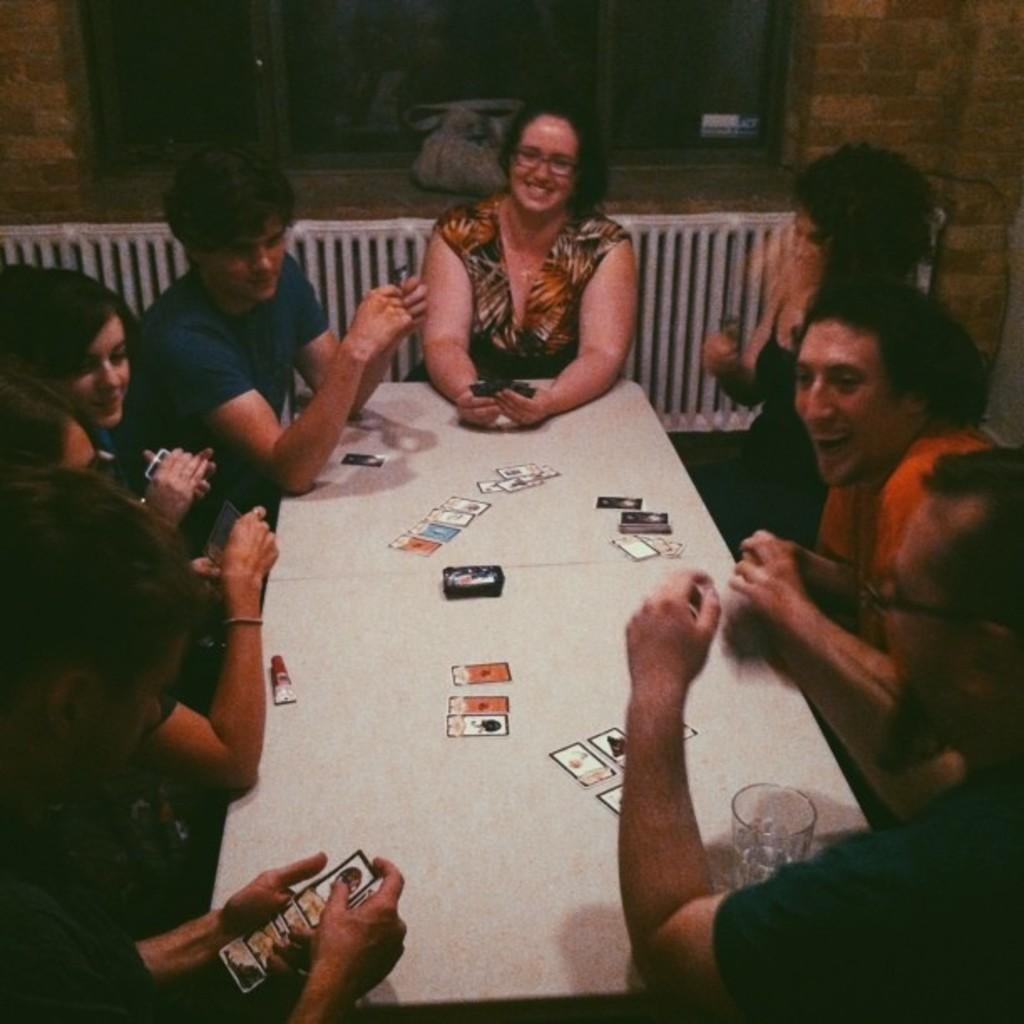What are the people in the image doing? The people in the image are sitting on chairs. What objects can be seen on the table in the image? There are cards on a table in the image. What type of pencil can be seen being used by the people in the image? There is no pencil present in the image. In which direction are the people facing in the image? The facts provided do not specify the direction the people are facing. What type of utensil is being used by the people in the image? The facts provided do not mention any utensils being used by the people in the image. 